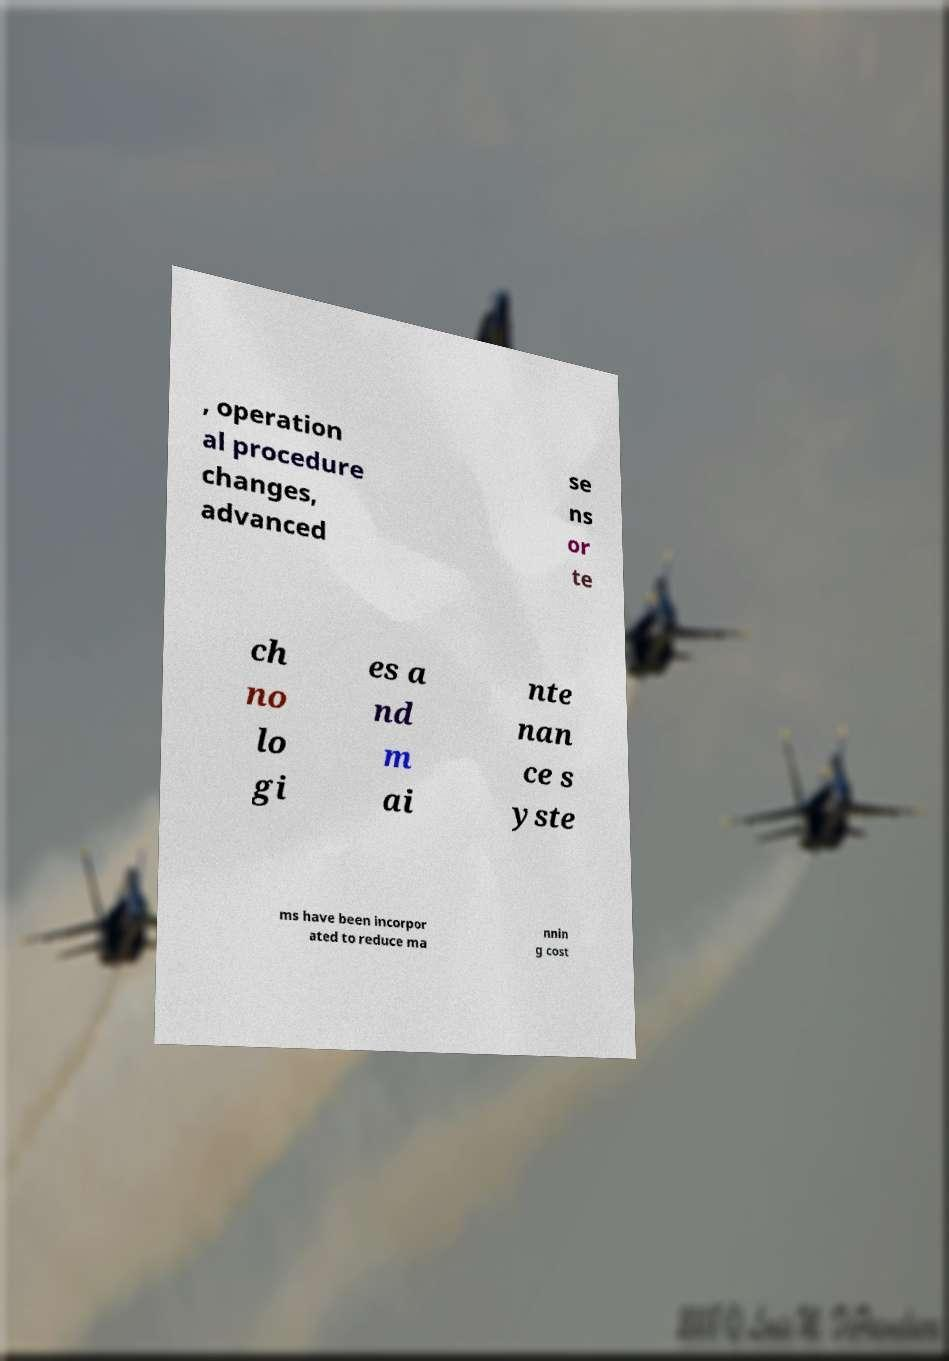Could you extract and type out the text from this image? , operation al procedure changes, advanced se ns or te ch no lo gi es a nd m ai nte nan ce s yste ms have been incorpor ated to reduce ma nnin g cost 